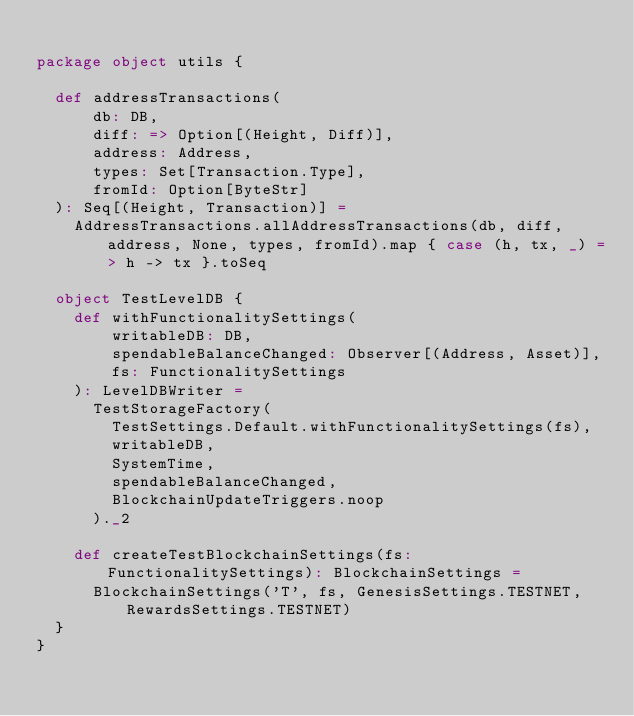<code> <loc_0><loc_0><loc_500><loc_500><_Scala_>
package object utils {

  def addressTransactions(
      db: DB,
      diff: => Option[(Height, Diff)],
      address: Address,
      types: Set[Transaction.Type],
      fromId: Option[ByteStr]
  ): Seq[(Height, Transaction)] =
    AddressTransactions.allAddressTransactions(db, diff, address, None, types, fromId).map { case (h, tx, _) => h -> tx }.toSeq

  object TestLevelDB {
    def withFunctionalitySettings(
        writableDB: DB,
        spendableBalanceChanged: Observer[(Address, Asset)],
        fs: FunctionalitySettings
    ): LevelDBWriter =
      TestStorageFactory(
        TestSettings.Default.withFunctionalitySettings(fs),
        writableDB,
        SystemTime,
        spendableBalanceChanged,
        BlockchainUpdateTriggers.noop
      )._2

    def createTestBlockchainSettings(fs: FunctionalitySettings): BlockchainSettings =
      BlockchainSettings('T', fs, GenesisSettings.TESTNET, RewardsSettings.TESTNET)
  }
}
</code> 